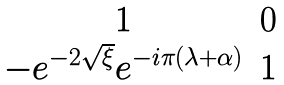<formula> <loc_0><loc_0><loc_500><loc_500>\begin{matrix} 1 & 0 \\ - e ^ { - 2 \sqrt { \xi } } e ^ { - i \pi ( \lambda + \alpha ) } & 1 \\ \end{matrix}</formula> 